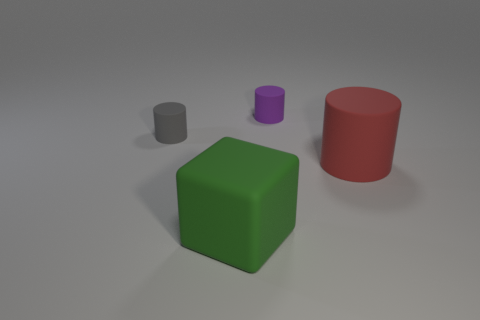Is the number of tiny cylinders less than the number of red cylinders?
Ensure brevity in your answer.  No. What number of gray rubber cylinders are the same size as the gray matte thing?
Keep it short and to the point. 0. What is the large green thing made of?
Provide a short and direct response. Rubber. There is a gray matte object behind the large red cylinder; what is its size?
Make the answer very short. Small. What number of other tiny things are the same shape as the small purple thing?
Offer a terse response. 1. What is the shape of the red object that is made of the same material as the large green thing?
Offer a very short reply. Cylinder. What number of red things are large cylinders or cylinders?
Keep it short and to the point. 1. There is a green object; are there any things on the right side of it?
Offer a terse response. Yes. There is a small matte thing that is to the right of the tiny gray cylinder; is its shape the same as the tiny matte thing that is on the left side of the purple rubber cylinder?
Offer a terse response. Yes. What material is the large red thing that is the same shape as the small purple rubber object?
Offer a terse response. Rubber. 